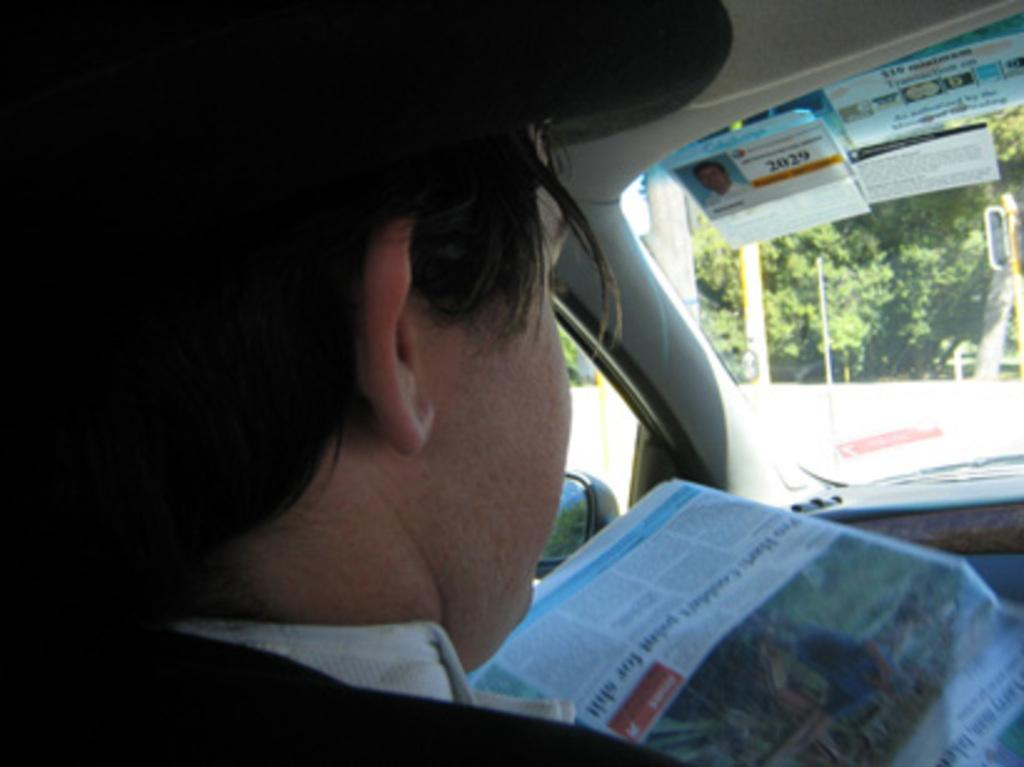What can be seen inside the vehicle in the image? There is a person inside the vehicle, as well as a newspaper and posters. What is used for personal grooming in the vehicle? There is a mirror in the vehicle for personal grooming. What feature is present on the vehicle to improve visibility during rain? There is a windscreen wiper on the vehicle to improve visibility during rain. What can be seen through the windscreen wiper in the image? Trees are visible through the windscreen wiper. What type of hat is the person wearing in the image? There is no hat visible in the image; the person is not wearing one. What type of brass instrument can be seen in the vehicle? There is no brass instrument present in the vehicle; the image only shows a person, newspaper, posters, mirror, windscreen wiper, and trees. 